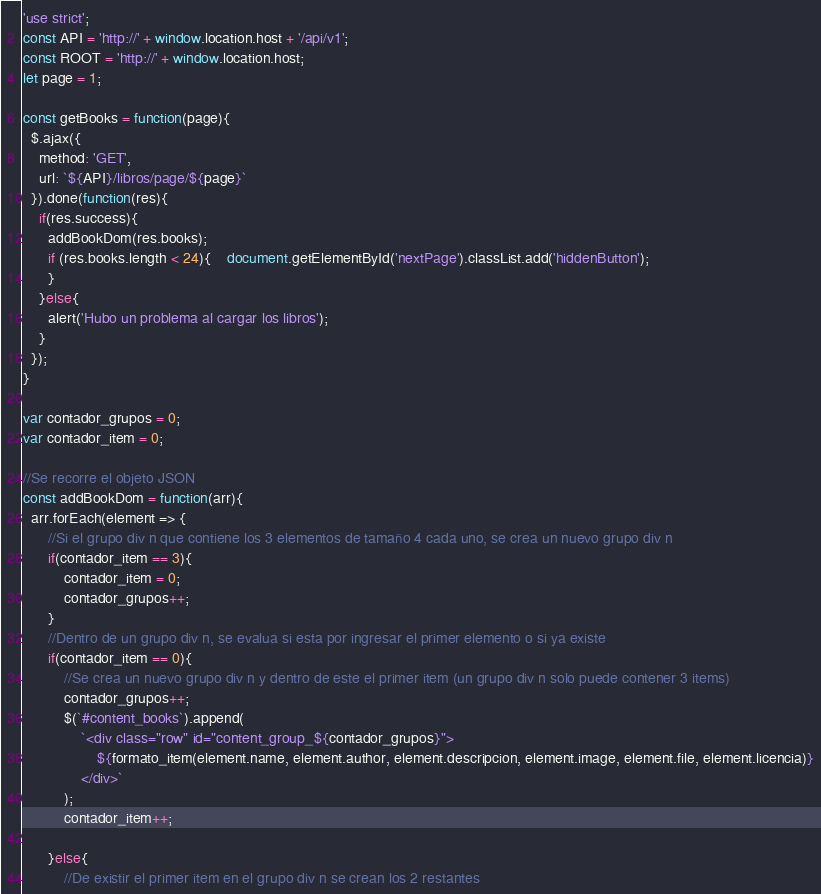<code> <loc_0><loc_0><loc_500><loc_500><_JavaScript_>'use strict';
const API = 'http://' + window.location.host + '/api/v1';
const ROOT = 'http://' + window.location.host;
let page = 1;

const getBooks = function(page){
  $.ajax({
    method: 'GET',
    url: `${API}/libros/page/${page}`
  }).done(function(res){
    if(res.success){
      addBookDom(res.books);
      if (res.books.length < 24){	document.getElementById('nextPage').classList.add('hiddenButton');
      }
    }else{
      alert('Hubo un problema al cargar los libros');
    }
  });
}

var contador_grupos = 0;
var contador_item = 0;

//Se recorre el objeto JSON
const addBookDom = function(arr){
  arr.forEach(element => {
      //Si el grupo div n que contiene los 3 elementos de tamaño 4 cada uno, se crea un nuevo grupo div n
      if(contador_item == 3){
          contador_item = 0;
          contador_grupos++;
      }
      //Dentro de un grupo div n, se evalua si esta por ingresar el primer elemento o si ya existe
      if(contador_item == 0){
          //Se crea un nuevo grupo div n y dentro de este el primer item (un grupo div n solo puede contener 3 items)
          contador_grupos++;
          $(`#content_books`).append(
              `<div class="row" id="content_group_${contador_grupos}">
                  ${formato_item(element.name, element.author, element.descripcion, element.image, element.file, element.licencia)}
              </div>`
          );
          contador_item++;

      }else{
          //De existir el primer item en el grupo div n se crean los 2 restantes</code> 